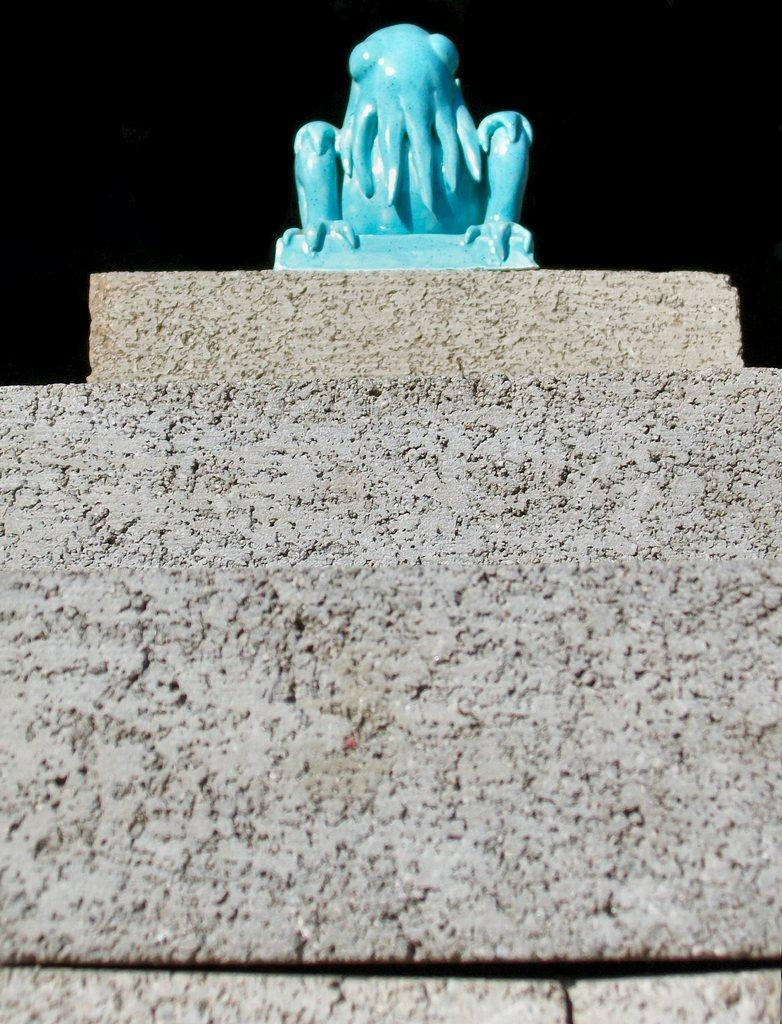What is the main subject in the foreground of the image? There is a statue in the foreground of the image. What is the statue standing on? The statue is on a stone. Are there any architectural features in the image? Yes, there are steps leading to the stone. What is the color of the background in the image? The background of the image is dark. What type of wood can be seen in the image? There is no wood present in the image. Is there a bed visible in the image? No, there is no bed present in the image. 